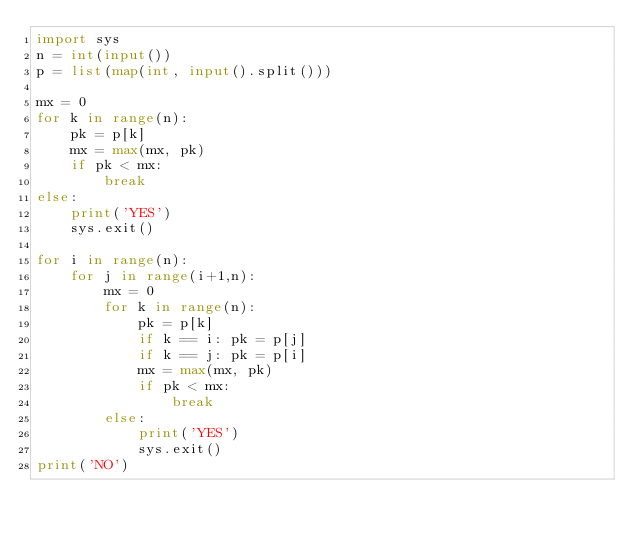Convert code to text. <code><loc_0><loc_0><loc_500><loc_500><_Python_>import sys
n = int(input())
p = list(map(int, input().split()))

mx = 0
for k in range(n):
    pk = p[k]
    mx = max(mx, pk)
    if pk < mx:
        break
else:
    print('YES')
    sys.exit()

for i in range(n):
    for j in range(i+1,n):
        mx = 0
        for k in range(n):
            pk = p[k]
            if k == i: pk = p[j]
            if k == j: pk = p[i]
            mx = max(mx, pk)
            if pk < mx:
                break
        else:
            print('YES')
            sys.exit()
print('NO')</code> 